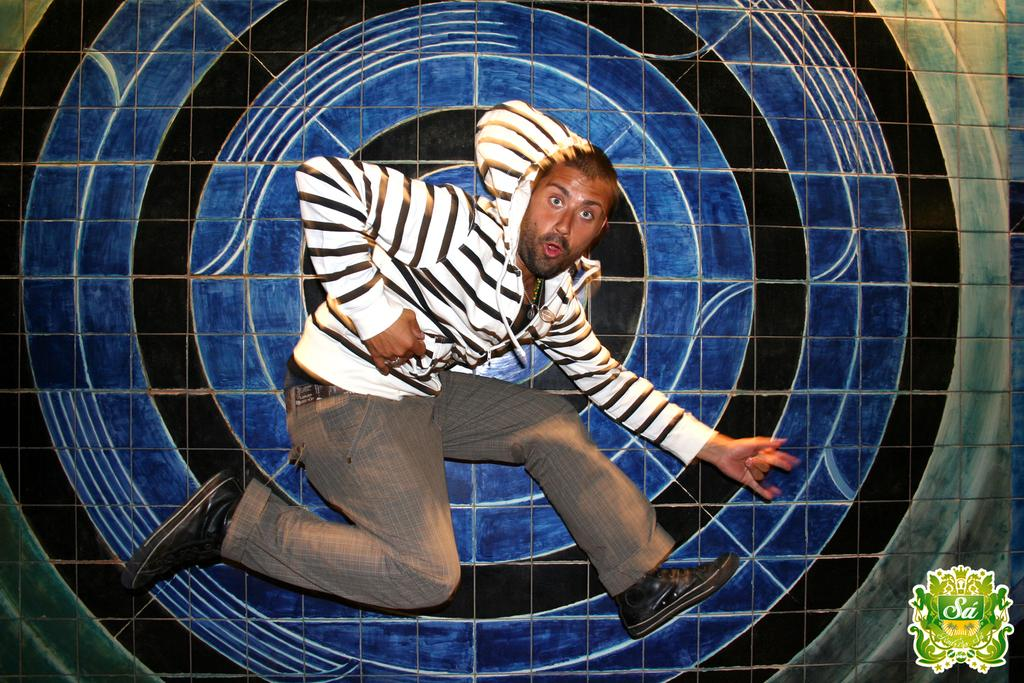What is the man in the image doing? The man is dancing in the image. What else can be seen in the image besides the man? There is a logo with text in the image. Where is the logo located in the image? The logo is located in the right side corner of the image. How would you describe the overall appearance of the image? The background of the image is colorful. How does the man use the cable to perform his dance moves in the image? There is no cable present in the image, and therefore no such interaction can be observed. 